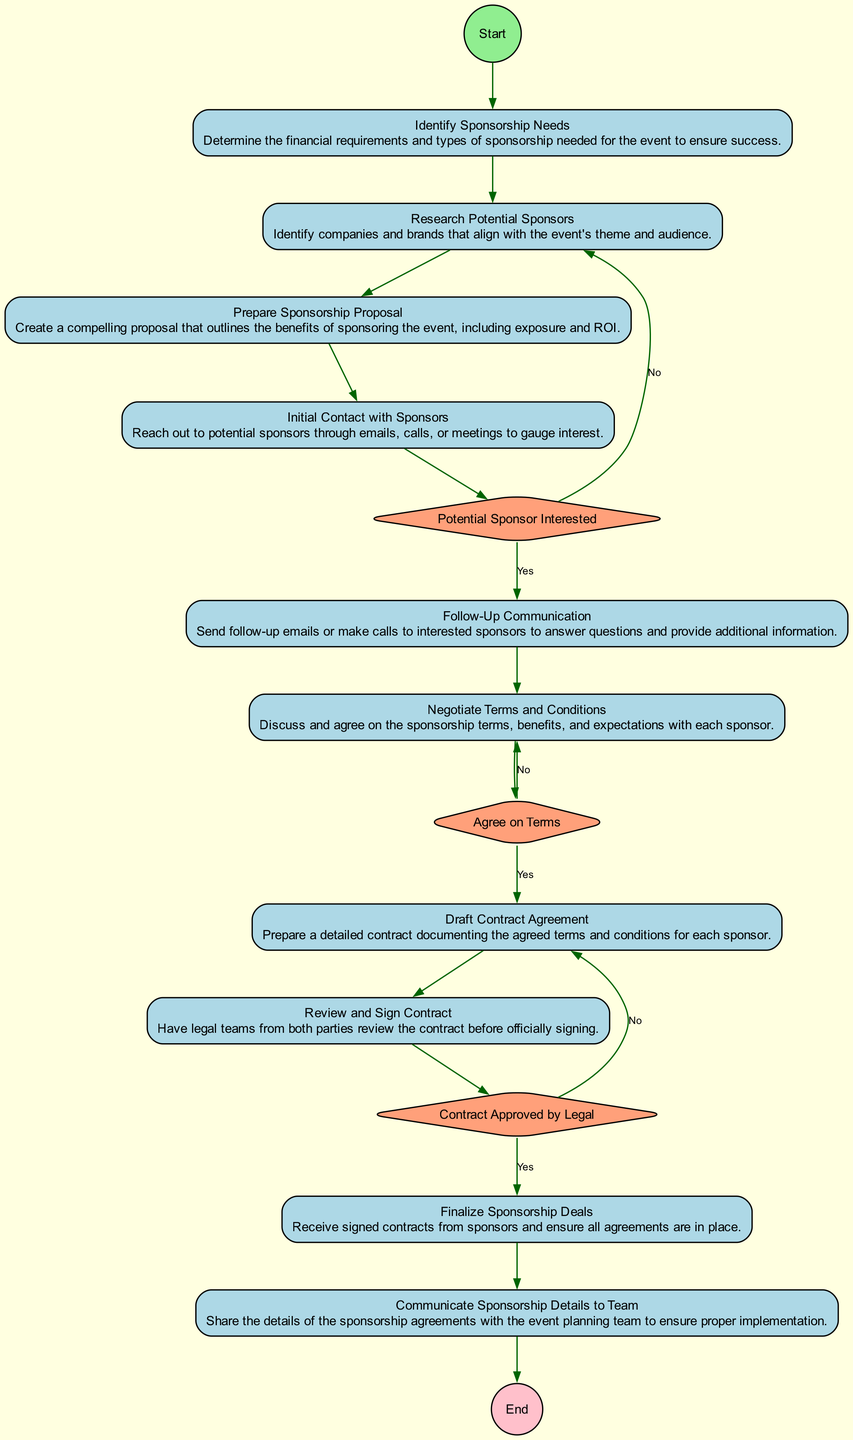What is the first activity in the diagram? The first activity, as indicated in the flowchart, is "Identify Sponsorship Needs." This is the starting point of the process to begin acquiring sponsorships.
Answer: Identify Sponsorship Needs How many activities are there in total? By counting the activities listed in the diagram, there are ten distinct activities presented for the sponsorship acquisition process.
Answer: 10 What is the last activity before the end point? The last activity before reaching the endpoint is "Communicate Sponsorship Details to Team," summarizing the final step in the process before concluding it.
Answer: Communicate Sponsorship Details to Team What happens if a potential sponsor is interested? If a potential sponsor expresses interest, the process proceeds to "Follow-Up Communication," where further engagement takes place to solidify the relationship.
Answer: Follow-Up Communication What decision point occurs after negotiating terms and conditions? After negotiating terms and conditions, the decision point is "Agree on Terms," where both parties determine if they are in agreement regarding the terms set forth.
Answer: Agree on Terms How many decision points are there in the diagram? There are three decision points depicted in the diagram related to the process of obtaining sponsorship, which serve as critical moments for determining the flow of activities.
Answer: 3 If the contract is not approved by legal, what is the next step? If the contract is not approved by legal, the process loops back to "Draft Contract Agreement," indicating that necessary revisions must be made prior to approval.
Answer: Draft Contract Agreement What activity follows the "Initial Contact with Sponsors"? Following "Initial Contact with Sponsors," the next activity is checking if the "Potential Sponsor Interested," which help directs the flow based on the level of interest shown.
Answer: Potential Sponsor Interested What indicates the successful completion of the sponsorship acquisition process? The successful completion is indicated by the activity "Finalize Sponsorship Deals," which is much further along in the flow and confirms that all contracts have been signed and secured.
Answer: Finalize Sponsorship Deals 